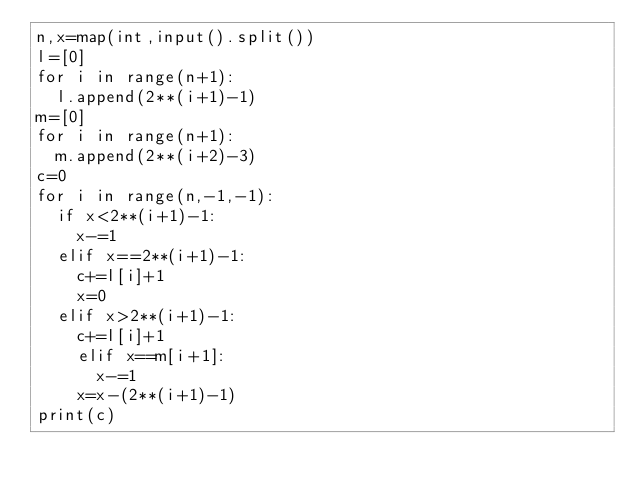<code> <loc_0><loc_0><loc_500><loc_500><_Python_>n,x=map(int,input().split())
l=[0]
for i in range(n+1):
  l.append(2**(i+1)-1)
m=[0]
for i in range(n+1):
  m.append(2**(i+2)-3)
c=0
for i in range(n,-1,-1):
  if x<2**(i+1)-1:
    x-=1
  elif x==2**(i+1)-1:
    c+=l[i]+1
    x=0
  elif x>2**(i+1)-1:
    c+=l[i]+1
    elif x==m[i+1]:
      x-=1
    x=x-(2**(i+1)-1)
print(c)</code> 